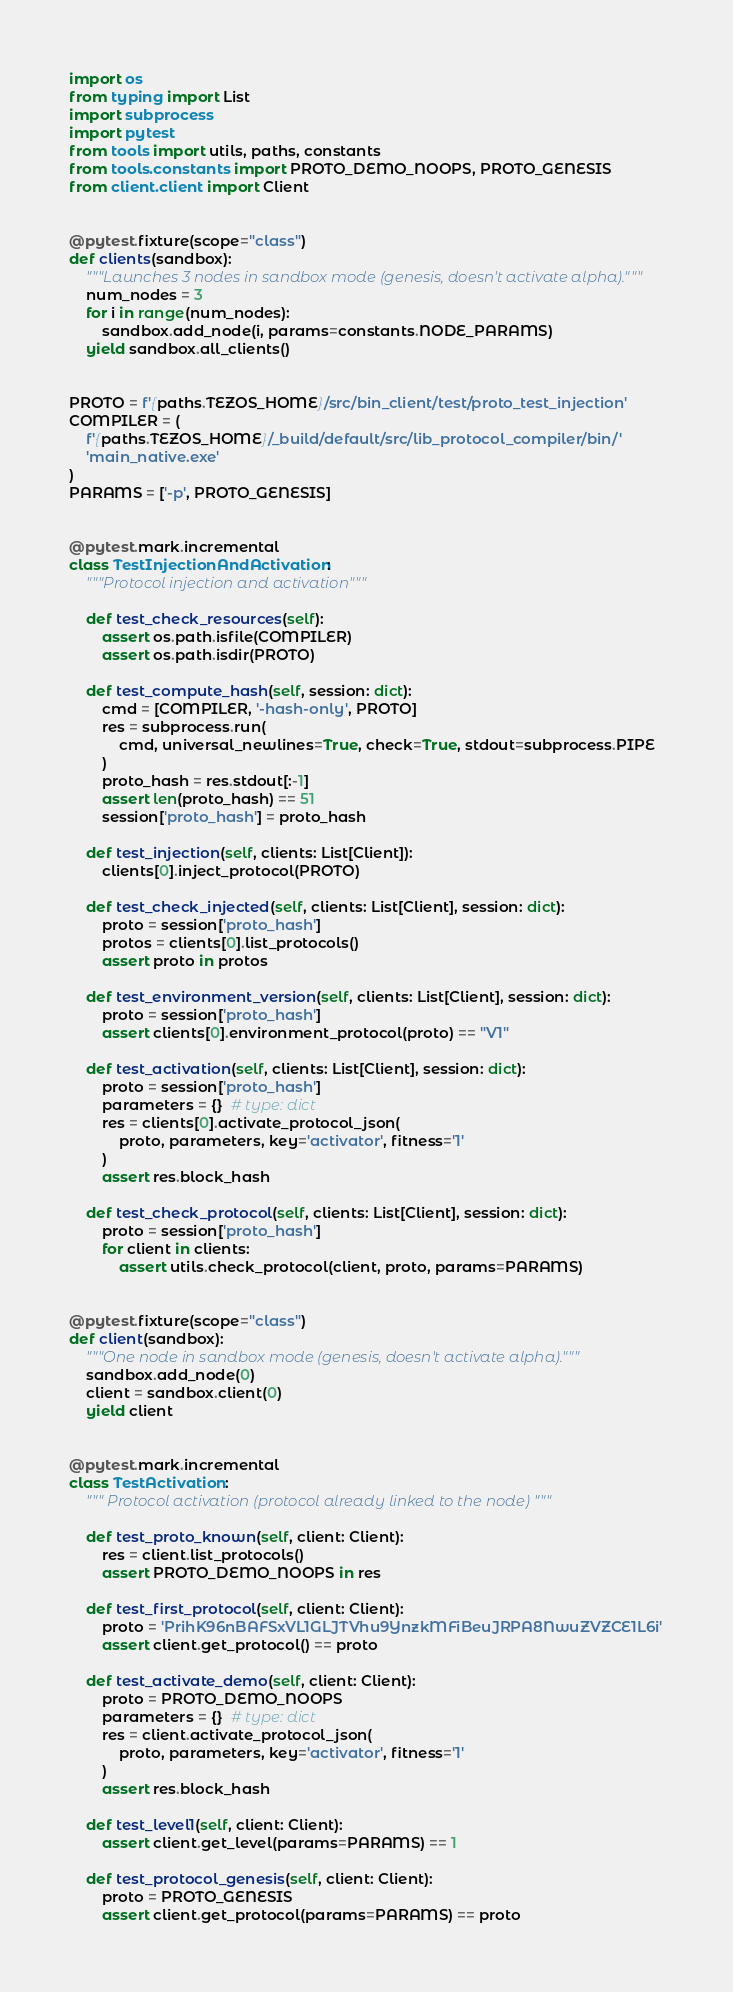<code> <loc_0><loc_0><loc_500><loc_500><_Python_>import os
from typing import List
import subprocess
import pytest
from tools import utils, paths, constants
from tools.constants import PROTO_DEMO_NOOPS, PROTO_GENESIS
from client.client import Client


@pytest.fixture(scope="class")
def clients(sandbox):
    """Launches 3 nodes in sandbox mode (genesis, doesn't activate alpha)."""
    num_nodes = 3
    for i in range(num_nodes):
        sandbox.add_node(i, params=constants.NODE_PARAMS)
    yield sandbox.all_clients()


PROTO = f'{paths.TEZOS_HOME}/src/bin_client/test/proto_test_injection'
COMPILER = (
    f'{paths.TEZOS_HOME}/_build/default/src/lib_protocol_compiler/bin/'
    'main_native.exe'
)
PARAMS = ['-p', PROTO_GENESIS]


@pytest.mark.incremental
class TestInjectionAndActivation:
    """Protocol injection and activation"""

    def test_check_resources(self):
        assert os.path.isfile(COMPILER)
        assert os.path.isdir(PROTO)

    def test_compute_hash(self, session: dict):
        cmd = [COMPILER, '-hash-only', PROTO]
        res = subprocess.run(
            cmd, universal_newlines=True, check=True, stdout=subprocess.PIPE
        )
        proto_hash = res.stdout[:-1]
        assert len(proto_hash) == 51
        session['proto_hash'] = proto_hash

    def test_injection(self, clients: List[Client]):
        clients[0].inject_protocol(PROTO)

    def test_check_injected(self, clients: List[Client], session: dict):
        proto = session['proto_hash']
        protos = clients[0].list_protocols()
        assert proto in protos

    def test_environment_version(self, clients: List[Client], session: dict):
        proto = session['proto_hash']
        assert clients[0].environment_protocol(proto) == "V1"

    def test_activation(self, clients: List[Client], session: dict):
        proto = session['proto_hash']
        parameters = {}  # type: dict
        res = clients[0].activate_protocol_json(
            proto, parameters, key='activator', fitness='1'
        )
        assert res.block_hash

    def test_check_protocol(self, clients: List[Client], session: dict):
        proto = session['proto_hash']
        for client in clients:
            assert utils.check_protocol(client, proto, params=PARAMS)


@pytest.fixture(scope="class")
def client(sandbox):
    """One node in sandbox mode (genesis, doesn't activate alpha)."""
    sandbox.add_node(0)
    client = sandbox.client(0)
    yield client


@pytest.mark.incremental
class TestActivation:
    """ Protocol activation (protocol already linked to the node) """

    def test_proto_known(self, client: Client):
        res = client.list_protocols()
        assert PROTO_DEMO_NOOPS in res

    def test_first_protocol(self, client: Client):
        proto = 'PrihK96nBAFSxVL1GLJTVhu9YnzkMFiBeuJRPA8NwuZVZCE1L6i'
        assert client.get_protocol() == proto

    def test_activate_demo(self, client: Client):
        proto = PROTO_DEMO_NOOPS
        parameters = {}  # type: dict
        res = client.activate_protocol_json(
            proto, parameters, key='activator', fitness='1'
        )
        assert res.block_hash

    def test_level1(self, client: Client):
        assert client.get_level(params=PARAMS) == 1

    def test_protocol_genesis(self, client: Client):
        proto = PROTO_GENESIS
        assert client.get_protocol(params=PARAMS) == proto
</code> 